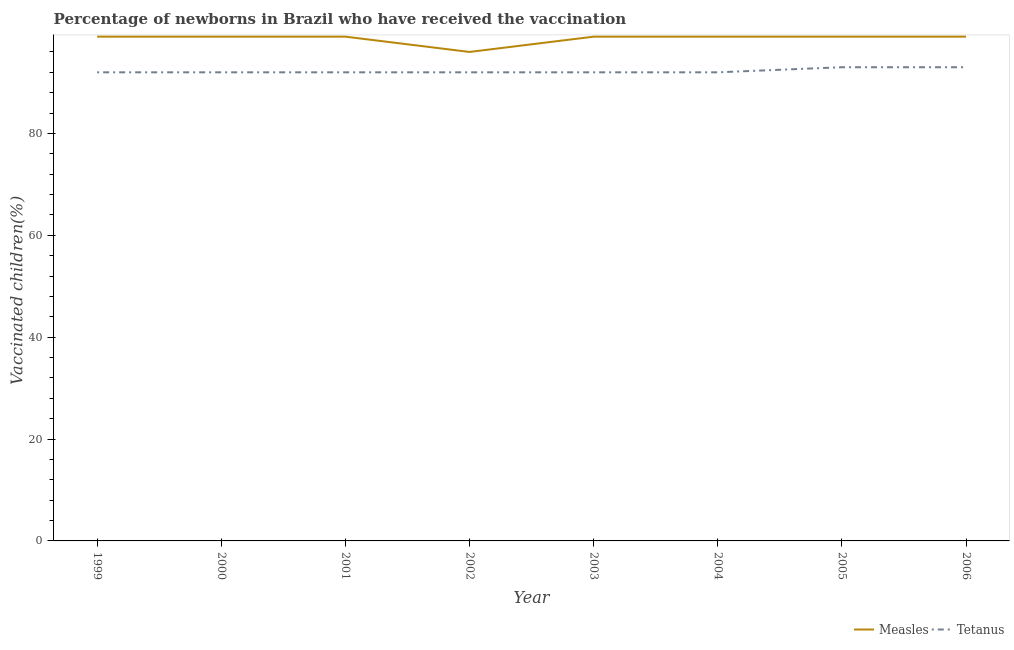Does the line corresponding to percentage of newborns who received vaccination for measles intersect with the line corresponding to percentage of newborns who received vaccination for tetanus?
Provide a short and direct response. No. Is the number of lines equal to the number of legend labels?
Offer a very short reply. Yes. What is the percentage of newborns who received vaccination for measles in 1999?
Keep it short and to the point. 99. Across all years, what is the maximum percentage of newborns who received vaccination for measles?
Provide a succinct answer. 99. Across all years, what is the minimum percentage of newborns who received vaccination for tetanus?
Make the answer very short. 92. In which year was the percentage of newborns who received vaccination for measles minimum?
Your response must be concise. 2002. What is the total percentage of newborns who received vaccination for measles in the graph?
Provide a short and direct response. 789. What is the difference between the percentage of newborns who received vaccination for measles in 2000 and that in 2002?
Provide a short and direct response. 3. What is the average percentage of newborns who received vaccination for measles per year?
Ensure brevity in your answer.  98.62. In the year 2004, what is the difference between the percentage of newborns who received vaccination for measles and percentage of newborns who received vaccination for tetanus?
Offer a terse response. 7. In how many years, is the percentage of newborns who received vaccination for measles greater than 92 %?
Provide a short and direct response. 8. What is the difference between the highest and the lowest percentage of newborns who received vaccination for tetanus?
Give a very brief answer. 1. In how many years, is the percentage of newborns who received vaccination for tetanus greater than the average percentage of newborns who received vaccination for tetanus taken over all years?
Give a very brief answer. 2. Does the percentage of newborns who received vaccination for tetanus monotonically increase over the years?
Make the answer very short. No. Is the percentage of newborns who received vaccination for measles strictly greater than the percentage of newborns who received vaccination for tetanus over the years?
Your answer should be very brief. Yes. How many lines are there?
Your answer should be compact. 2. How many years are there in the graph?
Offer a terse response. 8. What is the difference between two consecutive major ticks on the Y-axis?
Offer a very short reply. 20. Are the values on the major ticks of Y-axis written in scientific E-notation?
Offer a terse response. No. Does the graph contain any zero values?
Your answer should be very brief. No. Where does the legend appear in the graph?
Your response must be concise. Bottom right. What is the title of the graph?
Your answer should be very brief. Percentage of newborns in Brazil who have received the vaccination. Does "Chemicals" appear as one of the legend labels in the graph?
Your answer should be very brief. No. What is the label or title of the Y-axis?
Make the answer very short. Vaccinated children(%)
. What is the Vaccinated children(%)
 of Measles in 1999?
Offer a terse response. 99. What is the Vaccinated children(%)
 in Tetanus in 1999?
Ensure brevity in your answer.  92. What is the Vaccinated children(%)
 in Tetanus in 2000?
Give a very brief answer. 92. What is the Vaccinated children(%)
 in Tetanus in 2001?
Make the answer very short. 92. What is the Vaccinated children(%)
 in Measles in 2002?
Offer a terse response. 96. What is the Vaccinated children(%)
 in Tetanus in 2002?
Offer a terse response. 92. What is the Vaccinated children(%)
 of Measles in 2003?
Provide a short and direct response. 99. What is the Vaccinated children(%)
 of Tetanus in 2003?
Offer a very short reply. 92. What is the Vaccinated children(%)
 of Tetanus in 2004?
Keep it short and to the point. 92. What is the Vaccinated children(%)
 of Tetanus in 2005?
Keep it short and to the point. 93. What is the Vaccinated children(%)
 of Tetanus in 2006?
Provide a succinct answer. 93. Across all years, what is the maximum Vaccinated children(%)
 of Tetanus?
Ensure brevity in your answer.  93. Across all years, what is the minimum Vaccinated children(%)
 of Measles?
Make the answer very short. 96. Across all years, what is the minimum Vaccinated children(%)
 of Tetanus?
Make the answer very short. 92. What is the total Vaccinated children(%)
 in Measles in the graph?
Keep it short and to the point. 789. What is the total Vaccinated children(%)
 of Tetanus in the graph?
Offer a terse response. 738. What is the difference between the Vaccinated children(%)
 of Tetanus in 1999 and that in 2001?
Ensure brevity in your answer.  0. What is the difference between the Vaccinated children(%)
 in Measles in 1999 and that in 2003?
Make the answer very short. 0. What is the difference between the Vaccinated children(%)
 in Measles in 1999 and that in 2004?
Your answer should be very brief. 0. What is the difference between the Vaccinated children(%)
 in Measles in 2000 and that in 2001?
Keep it short and to the point. 0. What is the difference between the Vaccinated children(%)
 of Tetanus in 2000 and that in 2004?
Give a very brief answer. 0. What is the difference between the Vaccinated children(%)
 of Measles in 2000 and that in 2005?
Provide a succinct answer. 0. What is the difference between the Vaccinated children(%)
 of Tetanus in 2000 and that in 2005?
Give a very brief answer. -1. What is the difference between the Vaccinated children(%)
 in Measles in 2000 and that in 2006?
Make the answer very short. 0. What is the difference between the Vaccinated children(%)
 of Tetanus in 2000 and that in 2006?
Ensure brevity in your answer.  -1. What is the difference between the Vaccinated children(%)
 in Measles in 2001 and that in 2002?
Offer a terse response. 3. What is the difference between the Vaccinated children(%)
 of Measles in 2001 and that in 2003?
Provide a succinct answer. 0. What is the difference between the Vaccinated children(%)
 in Tetanus in 2001 and that in 2003?
Your answer should be compact. 0. What is the difference between the Vaccinated children(%)
 of Measles in 2001 and that in 2004?
Make the answer very short. 0. What is the difference between the Vaccinated children(%)
 in Tetanus in 2001 and that in 2004?
Your response must be concise. 0. What is the difference between the Vaccinated children(%)
 in Tetanus in 2001 and that in 2006?
Your answer should be compact. -1. What is the difference between the Vaccinated children(%)
 of Measles in 2002 and that in 2003?
Your answer should be very brief. -3. What is the difference between the Vaccinated children(%)
 in Tetanus in 2002 and that in 2003?
Provide a short and direct response. 0. What is the difference between the Vaccinated children(%)
 of Measles in 2002 and that in 2005?
Your answer should be compact. -3. What is the difference between the Vaccinated children(%)
 of Tetanus in 2002 and that in 2006?
Your answer should be compact. -1. What is the difference between the Vaccinated children(%)
 of Tetanus in 2003 and that in 2004?
Your answer should be compact. 0. What is the difference between the Vaccinated children(%)
 of Measles in 2003 and that in 2006?
Your answer should be very brief. 0. What is the difference between the Vaccinated children(%)
 in Tetanus in 2003 and that in 2006?
Offer a very short reply. -1. What is the difference between the Vaccinated children(%)
 in Measles in 2004 and that in 2005?
Your answer should be compact. 0. What is the difference between the Vaccinated children(%)
 of Measles in 2004 and that in 2006?
Make the answer very short. 0. What is the difference between the Vaccinated children(%)
 of Measles in 2005 and that in 2006?
Your answer should be very brief. 0. What is the difference between the Vaccinated children(%)
 in Tetanus in 2005 and that in 2006?
Give a very brief answer. 0. What is the difference between the Vaccinated children(%)
 in Measles in 1999 and the Vaccinated children(%)
 in Tetanus in 2000?
Give a very brief answer. 7. What is the difference between the Vaccinated children(%)
 of Measles in 1999 and the Vaccinated children(%)
 of Tetanus in 2002?
Provide a short and direct response. 7. What is the difference between the Vaccinated children(%)
 in Measles in 1999 and the Vaccinated children(%)
 in Tetanus in 2005?
Offer a very short reply. 6. What is the difference between the Vaccinated children(%)
 in Measles in 1999 and the Vaccinated children(%)
 in Tetanus in 2006?
Offer a terse response. 6. What is the difference between the Vaccinated children(%)
 of Measles in 2001 and the Vaccinated children(%)
 of Tetanus in 2002?
Your answer should be very brief. 7. What is the difference between the Vaccinated children(%)
 of Measles in 2001 and the Vaccinated children(%)
 of Tetanus in 2005?
Your answer should be compact. 6. What is the difference between the Vaccinated children(%)
 in Measles in 2002 and the Vaccinated children(%)
 in Tetanus in 2005?
Keep it short and to the point. 3. What is the difference between the Vaccinated children(%)
 of Measles in 2002 and the Vaccinated children(%)
 of Tetanus in 2006?
Your answer should be compact. 3. What is the difference between the Vaccinated children(%)
 in Measles in 2003 and the Vaccinated children(%)
 in Tetanus in 2004?
Make the answer very short. 7. What is the difference between the Vaccinated children(%)
 of Measles in 2004 and the Vaccinated children(%)
 of Tetanus in 2005?
Provide a succinct answer. 6. What is the difference between the Vaccinated children(%)
 of Measles in 2004 and the Vaccinated children(%)
 of Tetanus in 2006?
Offer a terse response. 6. What is the average Vaccinated children(%)
 of Measles per year?
Offer a very short reply. 98.62. What is the average Vaccinated children(%)
 in Tetanus per year?
Ensure brevity in your answer.  92.25. In the year 2003, what is the difference between the Vaccinated children(%)
 in Measles and Vaccinated children(%)
 in Tetanus?
Provide a short and direct response. 7. In the year 2005, what is the difference between the Vaccinated children(%)
 of Measles and Vaccinated children(%)
 of Tetanus?
Give a very brief answer. 6. In the year 2006, what is the difference between the Vaccinated children(%)
 of Measles and Vaccinated children(%)
 of Tetanus?
Your response must be concise. 6. What is the ratio of the Vaccinated children(%)
 of Measles in 1999 to that in 2000?
Provide a short and direct response. 1. What is the ratio of the Vaccinated children(%)
 in Measles in 1999 to that in 2002?
Your answer should be very brief. 1.03. What is the ratio of the Vaccinated children(%)
 of Measles in 1999 to that in 2004?
Ensure brevity in your answer.  1. What is the ratio of the Vaccinated children(%)
 in Measles in 1999 to that in 2005?
Provide a short and direct response. 1. What is the ratio of the Vaccinated children(%)
 of Measles in 1999 to that in 2006?
Ensure brevity in your answer.  1. What is the ratio of the Vaccinated children(%)
 of Tetanus in 1999 to that in 2006?
Make the answer very short. 0.99. What is the ratio of the Vaccinated children(%)
 in Measles in 2000 to that in 2001?
Ensure brevity in your answer.  1. What is the ratio of the Vaccinated children(%)
 in Tetanus in 2000 to that in 2001?
Provide a short and direct response. 1. What is the ratio of the Vaccinated children(%)
 of Measles in 2000 to that in 2002?
Keep it short and to the point. 1.03. What is the ratio of the Vaccinated children(%)
 in Tetanus in 2000 to that in 2002?
Give a very brief answer. 1. What is the ratio of the Vaccinated children(%)
 of Measles in 2000 to that in 2003?
Give a very brief answer. 1. What is the ratio of the Vaccinated children(%)
 in Measles in 2000 to that in 2004?
Give a very brief answer. 1. What is the ratio of the Vaccinated children(%)
 of Tetanus in 2000 to that in 2004?
Give a very brief answer. 1. What is the ratio of the Vaccinated children(%)
 of Tetanus in 2000 to that in 2005?
Your answer should be very brief. 0.99. What is the ratio of the Vaccinated children(%)
 in Measles in 2000 to that in 2006?
Offer a terse response. 1. What is the ratio of the Vaccinated children(%)
 of Measles in 2001 to that in 2002?
Ensure brevity in your answer.  1.03. What is the ratio of the Vaccinated children(%)
 of Tetanus in 2001 to that in 2003?
Make the answer very short. 1. What is the ratio of the Vaccinated children(%)
 of Tetanus in 2001 to that in 2004?
Ensure brevity in your answer.  1. What is the ratio of the Vaccinated children(%)
 in Measles in 2001 to that in 2006?
Offer a terse response. 1. What is the ratio of the Vaccinated children(%)
 of Measles in 2002 to that in 2003?
Provide a succinct answer. 0.97. What is the ratio of the Vaccinated children(%)
 in Measles in 2002 to that in 2004?
Your answer should be very brief. 0.97. What is the ratio of the Vaccinated children(%)
 of Measles in 2002 to that in 2005?
Provide a short and direct response. 0.97. What is the ratio of the Vaccinated children(%)
 in Measles in 2002 to that in 2006?
Your answer should be compact. 0.97. What is the ratio of the Vaccinated children(%)
 of Tetanus in 2002 to that in 2006?
Offer a terse response. 0.99. What is the ratio of the Vaccinated children(%)
 of Measles in 2003 to that in 2004?
Your response must be concise. 1. What is the ratio of the Vaccinated children(%)
 of Tetanus in 2003 to that in 2004?
Offer a very short reply. 1. What is the ratio of the Vaccinated children(%)
 of Measles in 2003 to that in 2005?
Offer a very short reply. 1. What is the ratio of the Vaccinated children(%)
 in Tetanus in 2003 to that in 2005?
Provide a short and direct response. 0.99. What is the ratio of the Vaccinated children(%)
 in Measles in 2003 to that in 2006?
Offer a very short reply. 1. What is the ratio of the Vaccinated children(%)
 of Measles in 2004 to that in 2005?
Provide a succinct answer. 1. What is the ratio of the Vaccinated children(%)
 of Tetanus in 2004 to that in 2005?
Provide a succinct answer. 0.99. What is the ratio of the Vaccinated children(%)
 in Tetanus in 2004 to that in 2006?
Provide a succinct answer. 0.99. What is the ratio of the Vaccinated children(%)
 of Tetanus in 2005 to that in 2006?
Your response must be concise. 1. What is the difference between the highest and the lowest Vaccinated children(%)
 of Tetanus?
Ensure brevity in your answer.  1. 